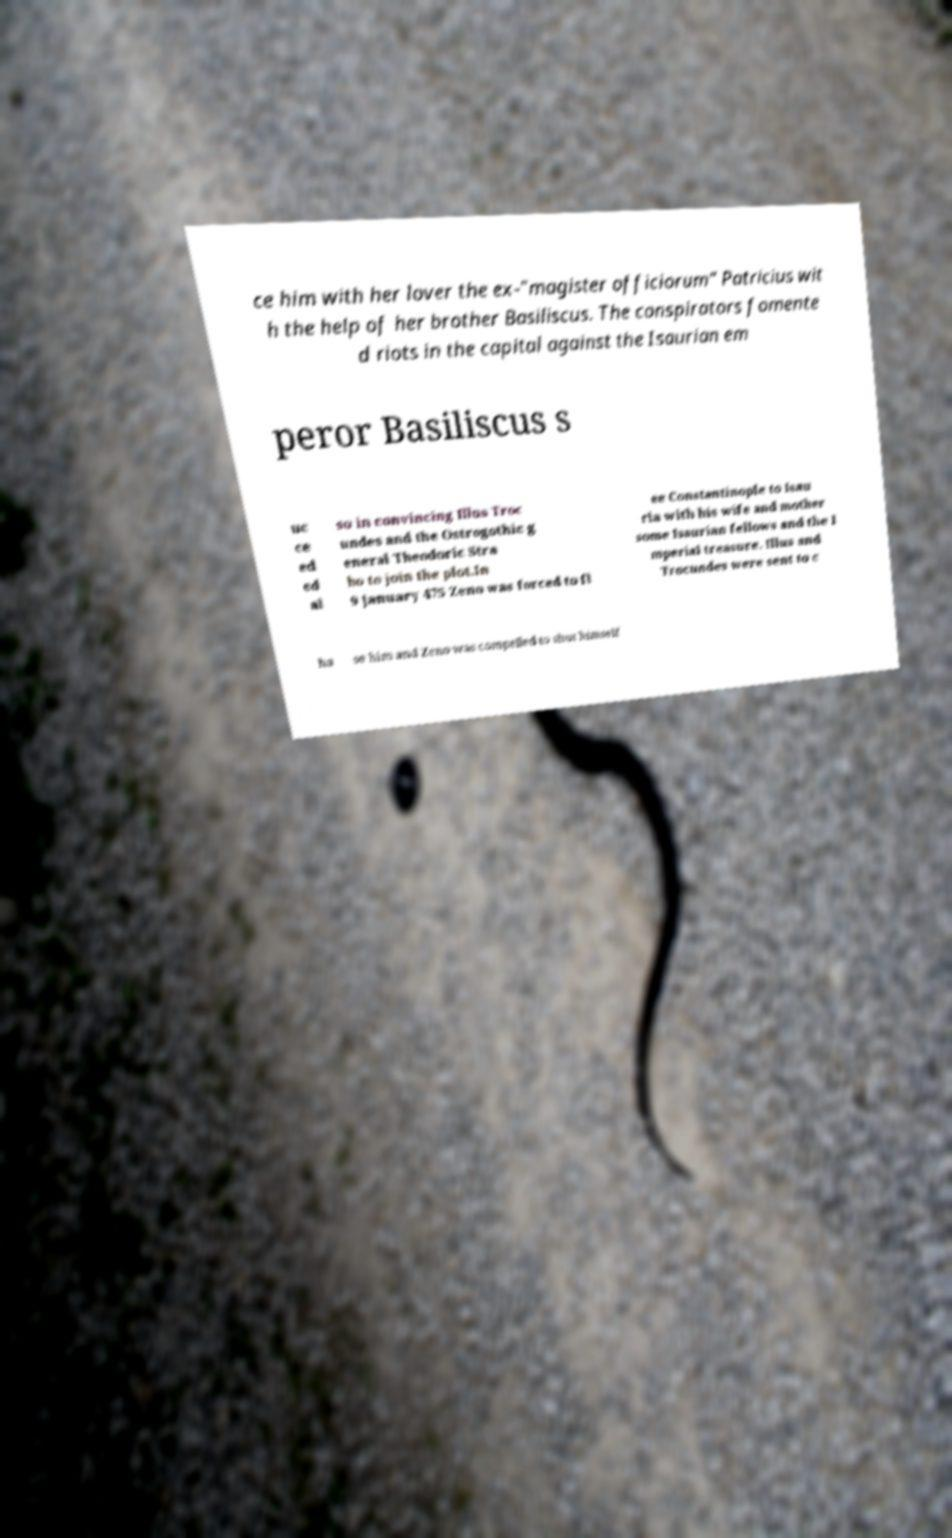Can you read and provide the text displayed in the image?This photo seems to have some interesting text. Can you extract and type it out for me? ce him with her lover the ex-"magister officiorum" Patricius wit h the help of her brother Basiliscus. The conspirators fomente d riots in the capital against the Isaurian em peror Basiliscus s uc ce ed ed al so in convincing Illus Troc undes and the Ostrogothic g eneral Theodoric Stra bo to join the plot.In 9 January 475 Zeno was forced to fl ee Constantinople to Isau ria with his wife and mother some Isaurian fellows and the I mperial treasure. Illus and Trocundes were sent to c ha se him and Zeno was compelled to shut himself 